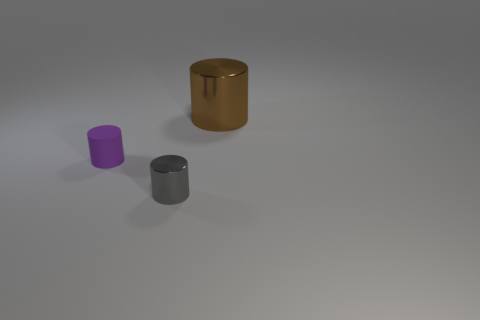Subtract all purple rubber cylinders. How many cylinders are left? 2 Subtract 0 yellow cubes. How many objects are left? 3 Subtract 3 cylinders. How many cylinders are left? 0 Subtract all blue cylinders. Subtract all blue spheres. How many cylinders are left? 3 Subtract all purple spheres. How many gray cylinders are left? 1 Subtract all tiny gray things. Subtract all large things. How many objects are left? 1 Add 1 brown shiny objects. How many brown shiny objects are left? 2 Add 2 purple rubber things. How many purple rubber things exist? 3 Add 1 large brown metallic things. How many objects exist? 4 